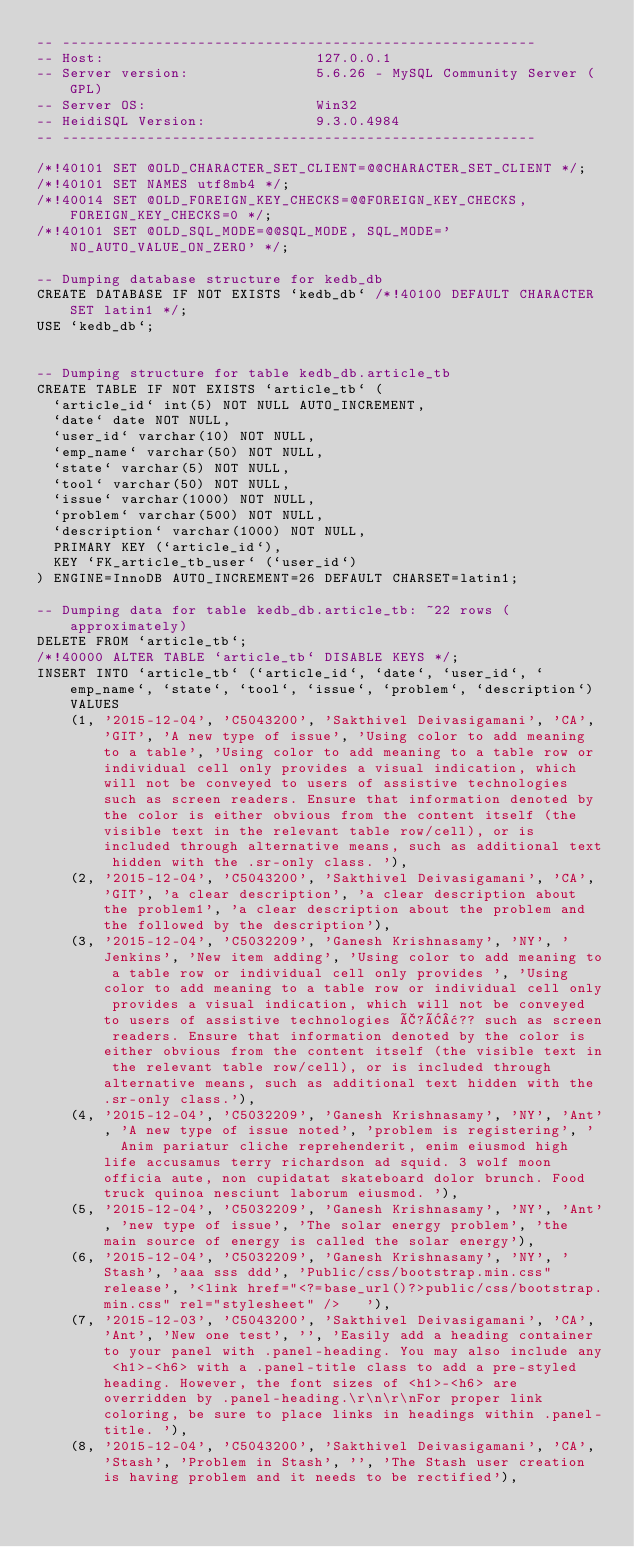<code> <loc_0><loc_0><loc_500><loc_500><_SQL_>-- --------------------------------------------------------
-- Host:                         127.0.0.1
-- Server version:               5.6.26 - MySQL Community Server (GPL)
-- Server OS:                    Win32
-- HeidiSQL Version:             9.3.0.4984
-- --------------------------------------------------------

/*!40101 SET @OLD_CHARACTER_SET_CLIENT=@@CHARACTER_SET_CLIENT */;
/*!40101 SET NAMES utf8mb4 */;
/*!40014 SET @OLD_FOREIGN_KEY_CHECKS=@@FOREIGN_KEY_CHECKS, FOREIGN_KEY_CHECKS=0 */;
/*!40101 SET @OLD_SQL_MODE=@@SQL_MODE, SQL_MODE='NO_AUTO_VALUE_ON_ZERO' */;

-- Dumping database structure for kedb_db
CREATE DATABASE IF NOT EXISTS `kedb_db` /*!40100 DEFAULT CHARACTER SET latin1 */;
USE `kedb_db`;


-- Dumping structure for table kedb_db.article_tb
CREATE TABLE IF NOT EXISTS `article_tb` (
  `article_id` int(5) NOT NULL AUTO_INCREMENT,
  `date` date NOT NULL,
  `user_id` varchar(10) NOT NULL,
  `emp_name` varchar(50) NOT NULL,
  `state` varchar(5) NOT NULL,
  `tool` varchar(50) NOT NULL,
  `issue` varchar(1000) NOT NULL,
  `problem` varchar(500) NOT NULL,
  `description` varchar(1000) NOT NULL,
  PRIMARY KEY (`article_id`),
  KEY `FK_article_tb_user` (`user_id`)
) ENGINE=InnoDB AUTO_INCREMENT=26 DEFAULT CHARSET=latin1;

-- Dumping data for table kedb_db.article_tb: ~22 rows (approximately)
DELETE FROM `article_tb`;
/*!40000 ALTER TABLE `article_tb` DISABLE KEYS */;
INSERT INTO `article_tb` (`article_id`, `date`, `user_id`, `emp_name`, `state`, `tool`, `issue`, `problem`, `description`) VALUES
	(1, '2015-12-04', 'C5043200', 'Sakthivel Deivasigamani', 'CA', 'GIT', 'A new type of issue', 'Using color to add meaning to a table', 'Using color to add meaning to a table row or individual cell only provides a visual indication, which will not be conveyed to users of assistive technologies such as screen readers. Ensure that information denoted by the color is either obvious from the content itself (the visible text in the relevant table row/cell), or is included through alternative means, such as additional text hidden with the .sr-only class. '),
	(2, '2015-12-04', 'C5043200', 'Sakthivel Deivasigamani', 'CA', 'GIT', 'a clear description', 'a clear description about the problem1', 'a clear description about the problem and the followed by the description'),
	(3, '2015-12-04', 'C5032209', 'Ganesh Krishnasamy', 'NY', 'Jenkins', 'New item adding', 'Using color to add meaning to a table row or individual cell only provides ', 'Using color to add meaning to a table row or individual cell only provides a visual indication, which will not be conveyed to users of assistive technologies Ã?Â¢?? such as screen readers. Ensure that information denoted by the color is either obvious from the content itself (the visible text in the relevant table row/cell), or is included through alternative means, such as additional text hidden with the .sr-only class.'),
	(4, '2015-12-04', 'C5032209', 'Ganesh Krishnasamy', 'NY', 'Ant', 'A new type of issue noted', 'problem is registering', '   Anim pariatur cliche reprehenderit, enim eiusmod high life accusamus terry richardson ad squid. 3 wolf moon officia aute, non cupidatat skateboard dolor brunch. Food truck quinoa nesciunt laborum eiusmod. '),
	(5, '2015-12-04', 'C5032209', 'Ganesh Krishnasamy', 'NY', 'Ant', 'new type of issue', 'The solar energy problem', 'the main source of energy is called the solar energy'),
	(6, '2015-12-04', 'C5032209', 'Ganesh Krishnasamy', 'NY', 'Stash', 'aaa sss ddd', 'Public/css/bootstrap.min.css" release', '<link href="<?=base_url()?>public/css/bootstrap.min.css" rel="stylesheet" />   '),
	(7, '2015-12-03', 'C5043200', 'Sakthivel Deivasigamani', 'CA', 'Ant', 'New one test', '', 'Easily add a heading container to your panel with .panel-heading. You may also include any <h1>-<h6> with a .panel-title class to add a pre-styled heading. However, the font sizes of <h1>-<h6> are overridden by .panel-heading.\r\n\r\nFor proper link coloring, be sure to place links in headings within .panel-title. '),
	(8, '2015-12-04', 'C5043200', 'Sakthivel Deivasigamani', 'CA', 'Stash', 'Problem in Stash', '', 'The Stash user creation is having problem and it needs to be rectified'),</code> 